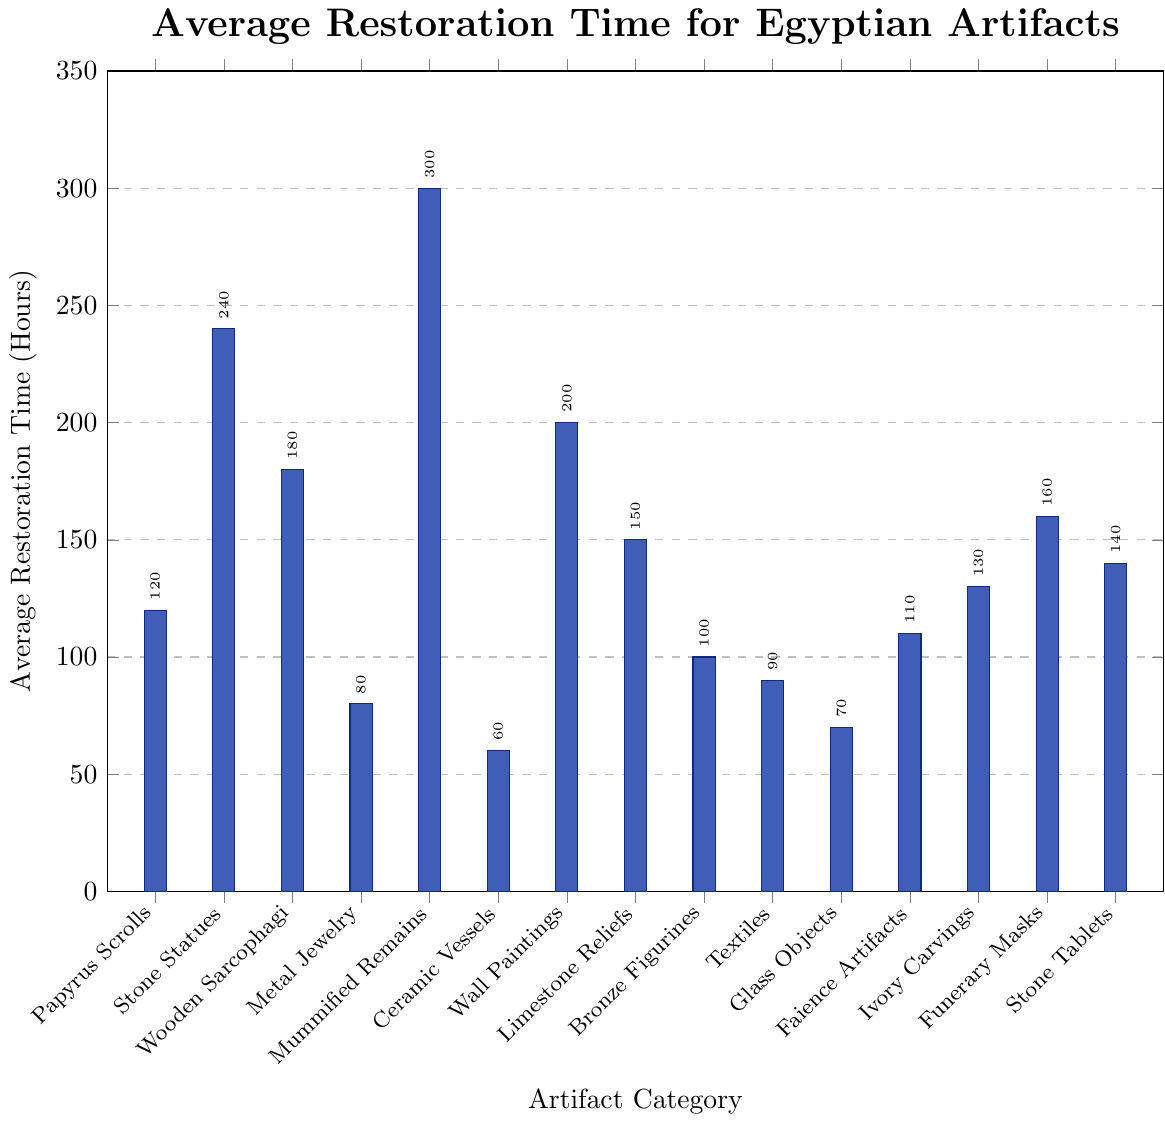Which category of Egyptian artifacts takes the longest restoration time? From the figure, the tallest bar indicates the category with the longest restoration time. The tallest bar corresponds to Mummified Remains with an average restoration time of 300 hours.
Answer: Mummified Remains What is the difference in restoration time between Wooden Sarcophagi and Metal Jewelry? From the figure, the bar height for Wooden Sarcophagi is 180 hours and for Metal Jewelry it is 80 hours. The difference between them is 180 - 80 = 100 hours.
Answer: 100 hours Which category has a shorter average restoration time: Bronze Figurines or Textiles? The bar for Bronze Figurines shows 100 hours, whereas the bar for Textiles shows 90 hours. Since 90 is less than 100, Textiles have a shorter average restoration time.
Answer: Textiles What is the average restoration time for Papyrus Scrolls, Stone Tablets, and Glass Objects combined? The restoration times are 120 hours for Papyrus Scrolls, 140 hours for Stone Tablets, and 70 hours for Glass Objects. Sum these times: 120 + 140 + 70 = 330 hours. Then, divide by the number of categories (3): 330 / 3 = 110 hours.
Answer: 110 hours Which two categories have the closest restoration times? Observing the bars, Faience Artifacts (110 hours) and Bronze Figurines (100 hours) are closest, with only a 10-hour difference.
Answer: Faience Artifacts and Bronze Figurines Is the average restoration time for Wall Paintings longer than for Limestone Reliefs? The bar for Wall Paintings shows 200 hours, while the bar for Limestone Reliefs shows 150 hours. Since 200 is greater than 150, Wall Paintings take longer.
Answer: Yes Are there any categories with an average restoration time of exactly 150 hours? By inspecting the figure, the Limestone Reliefs category has a bar precisely at 150 hours.
Answer: Yes What is the combined restoration time of the three artifacts requiring the shortest time? The three shortest times are Ceramic Vessels (60 hours), Glass Objects (70 hours), and Metal Jewelry (80 hours). Sum these times: 60 + 70 + 80 = 210 hours.
Answer: 210 hours How much longer does it take to restore Mummified Remains compared to Papyrus Scrolls? The bar for Mummified Remains indicates 300 hours, and the bar for Papyrus Scrolls shows 120 hours. The difference is 300 - 120 = 180 hours.
Answer: 180 hours 